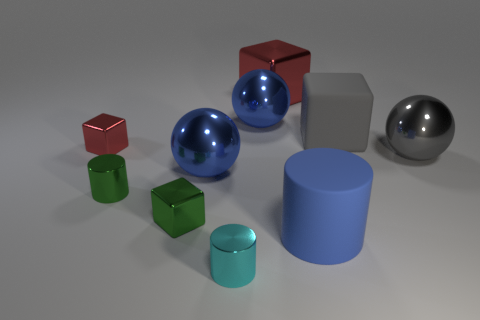The other tiny shiny object that is the same shape as the tiny cyan metal object is what color?
Provide a short and direct response. Green. There is a metallic thing right of the large shiny cube; what is its shape?
Make the answer very short. Sphere. There is a blue rubber cylinder; are there any big blue objects in front of it?
Your answer should be very brief. No. Is there anything else that has the same size as the cyan shiny thing?
Your answer should be compact. Yes. There is a cylinder that is the same material as the gray block; what is its color?
Your answer should be compact. Blue. There is a shiny cylinder that is to the left of the tiny cyan metal cylinder; does it have the same color as the matte thing that is behind the green block?
Provide a short and direct response. No. What number of balls are large gray objects or blue objects?
Your answer should be very brief. 3. Are there an equal number of blue cylinders on the right side of the large red thing and red metal spheres?
Provide a succinct answer. No. There is a large blue thing that is on the left side of the large blue metal ball that is behind the ball that is right of the large matte cylinder; what is its material?
Ensure brevity in your answer.  Metal. There is a object that is the same color as the big rubber cube; what is its material?
Offer a terse response. Metal. 